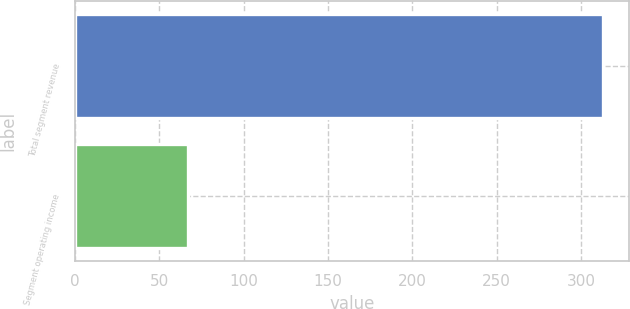Convert chart. <chart><loc_0><loc_0><loc_500><loc_500><bar_chart><fcel>Total segment revenue<fcel>Segment operating income<nl><fcel>313<fcel>67<nl></chart> 